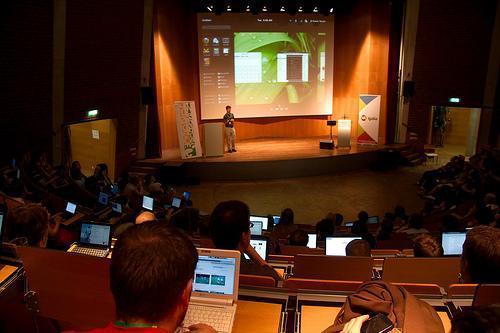How many people are on the stage?
Give a very brief answer. 1. 